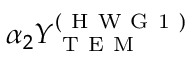Convert formula to latex. <formula><loc_0><loc_0><loc_500><loc_500>\alpha _ { 2 } Y _ { T E M } ^ { ( H W G 1 ) }</formula> 